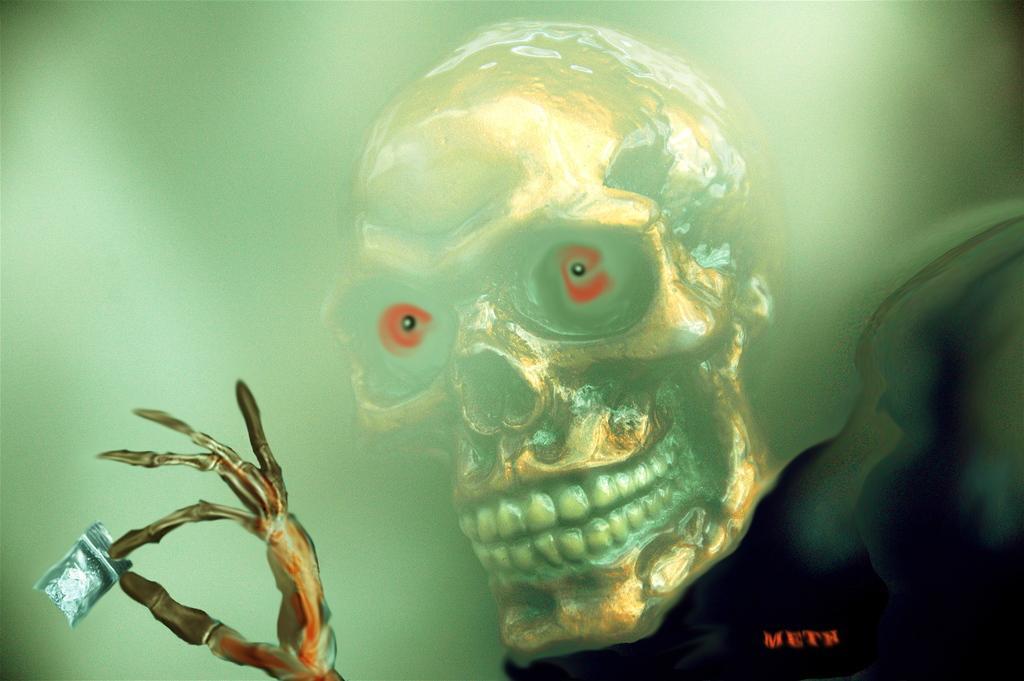Could you give a brief overview of what you see in this image? In this image we can see the animated picture of a skull. 